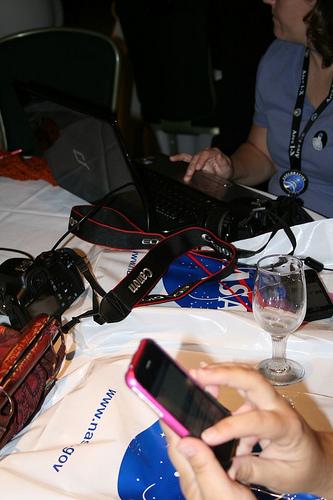To which government organization do the two large blue logos belong to?
Short answer required. Nasa. What is the brand name of the camera?
Concise answer only. Canon. What color is the phone case?
Short answer required. Pink. 